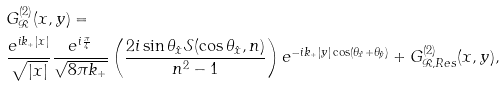Convert formula to latex. <formula><loc_0><loc_0><loc_500><loc_500>& G ^ { ( 2 ) } _ { \mathcal { R } } ( x , y ) = \\ & \frac { e ^ { i k _ { + } | x | } } { \sqrt { | x | } } \frac { e ^ { i \frac { \pi } 4 } } { \sqrt { 8 \pi k _ { + } } } \left ( \frac { 2 i \sin \theta _ { \hat { x } } \mathcal { S } ( \cos \theta _ { \hat { x } } , n ) } { n ^ { 2 } - 1 } \right ) e ^ { - i k _ { + } | y | \cos ( \theta _ { \hat { x } } + \theta _ { \hat { y } } ) } + G ^ { ( 2 ) } _ { \mathcal { R } , R e s } ( x , y ) ,</formula> 